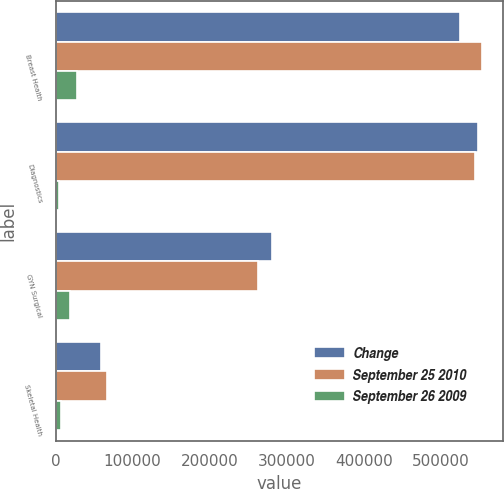Convert chart. <chart><loc_0><loc_0><loc_500><loc_500><stacked_bar_chart><ecel><fcel>Breast Health<fcel>Diagnostics<fcel>GYN Surgical<fcel>Skeletal Health<nl><fcel>Change<fcel>525622<fcel>548832<fcel>281364<fcel>59082<nl><fcel>September 25 2010<fcel>553065<fcel>544143<fcel>263187<fcel>66591<nl><fcel>September 26 2009<fcel>27443<fcel>4689<fcel>18177<fcel>7509<nl></chart> 